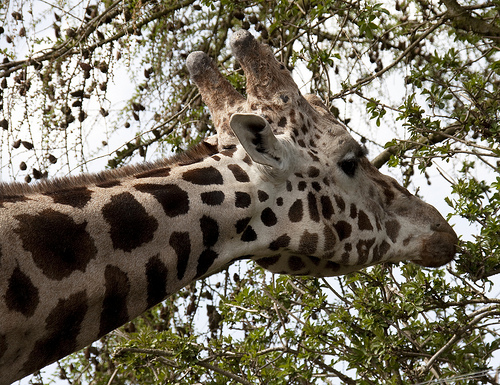<image>
Is there a tree above the giraffe? Yes. The tree is positioned above the giraffe in the vertical space, higher up in the scene. 